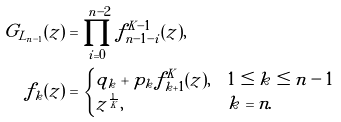Convert formula to latex. <formula><loc_0><loc_0><loc_500><loc_500>G _ { L _ { n - 1 } } ( z ) & = \prod _ { i = 0 } ^ { n - 2 } f _ { n - 1 - i } ^ { K - 1 } ( z ) , \\ f _ { k } ( z ) & = \begin{cases} q _ { k } + p _ { k } f _ { k + 1 } ^ { K } ( z ) , & 1 \leq k \leq n - 1 \\ z ^ { \frac { 1 } { K } } , & k = n . \end{cases}</formula> 